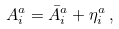Convert formula to latex. <formula><loc_0><loc_0><loc_500><loc_500>A ^ { a } _ { i } = \bar { A } ^ { a } _ { i } + \eta ^ { a } _ { i } \, ,</formula> 